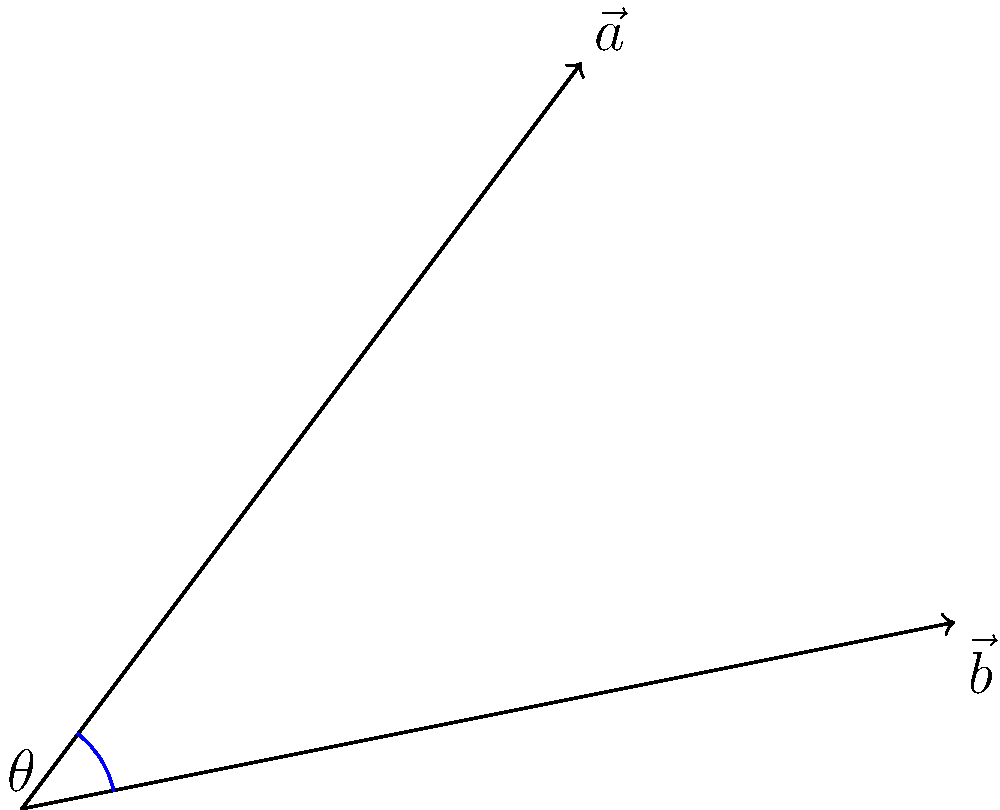In your latest Alpha and Omega-themed wallpaper, you've represented Alpha's position with vector $\vec{a} = (3, 4)$ and Omega's position with vector $\vec{b} = (5, 1)$. What is the angle $\theta$ between these two vectors? To find the angle between two vectors, we can use the dot product formula:

$$\cos \theta = \frac{\vec{a} \cdot \vec{b}}{|\vec{a}||\vec{b}|}$$

Step 1: Calculate the dot product $\vec{a} \cdot \vec{b}$
$$\vec{a} \cdot \vec{b} = (3 \times 5) + (4 \times 1) = 15 + 4 = 19$$

Step 2: Calculate the magnitudes of $\vec{a}$ and $\vec{b}$
$$|\vec{a}| = \sqrt{3^2 + 4^2} = \sqrt{9 + 16} = \sqrt{25} = 5$$
$$|\vec{b}| = \sqrt{5^2 + 1^2} = \sqrt{25 + 1} = \sqrt{26}$$

Step 3: Apply the formula
$$\cos \theta = \frac{19}{5\sqrt{26}}$$

Step 4: Take the inverse cosine (arccos) of both sides
$$\theta = \arccos(\frac{19}{5\sqrt{26}})$$

Step 5: Calculate the result (in radians)
$$\theta \approx 0.3398 \text{ radians}$$

Step 6: Convert to degrees
$$\theta \approx 0.3398 \times \frac{180}{\pi} \approx 19.47°$$
Answer: 19.47° 